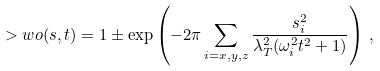<formula> <loc_0><loc_0><loc_500><loc_500>> w o ( { s } , t ) = 1 \pm \exp \left ( - 2 \pi \sum _ { i = x , y , z } \frac { s ^ { 2 } _ { i } } { \lambda _ { T } ^ { 2 } ( \omega ^ { 2 } _ { i } t ^ { 2 } + 1 ) } \right ) \, ,</formula> 